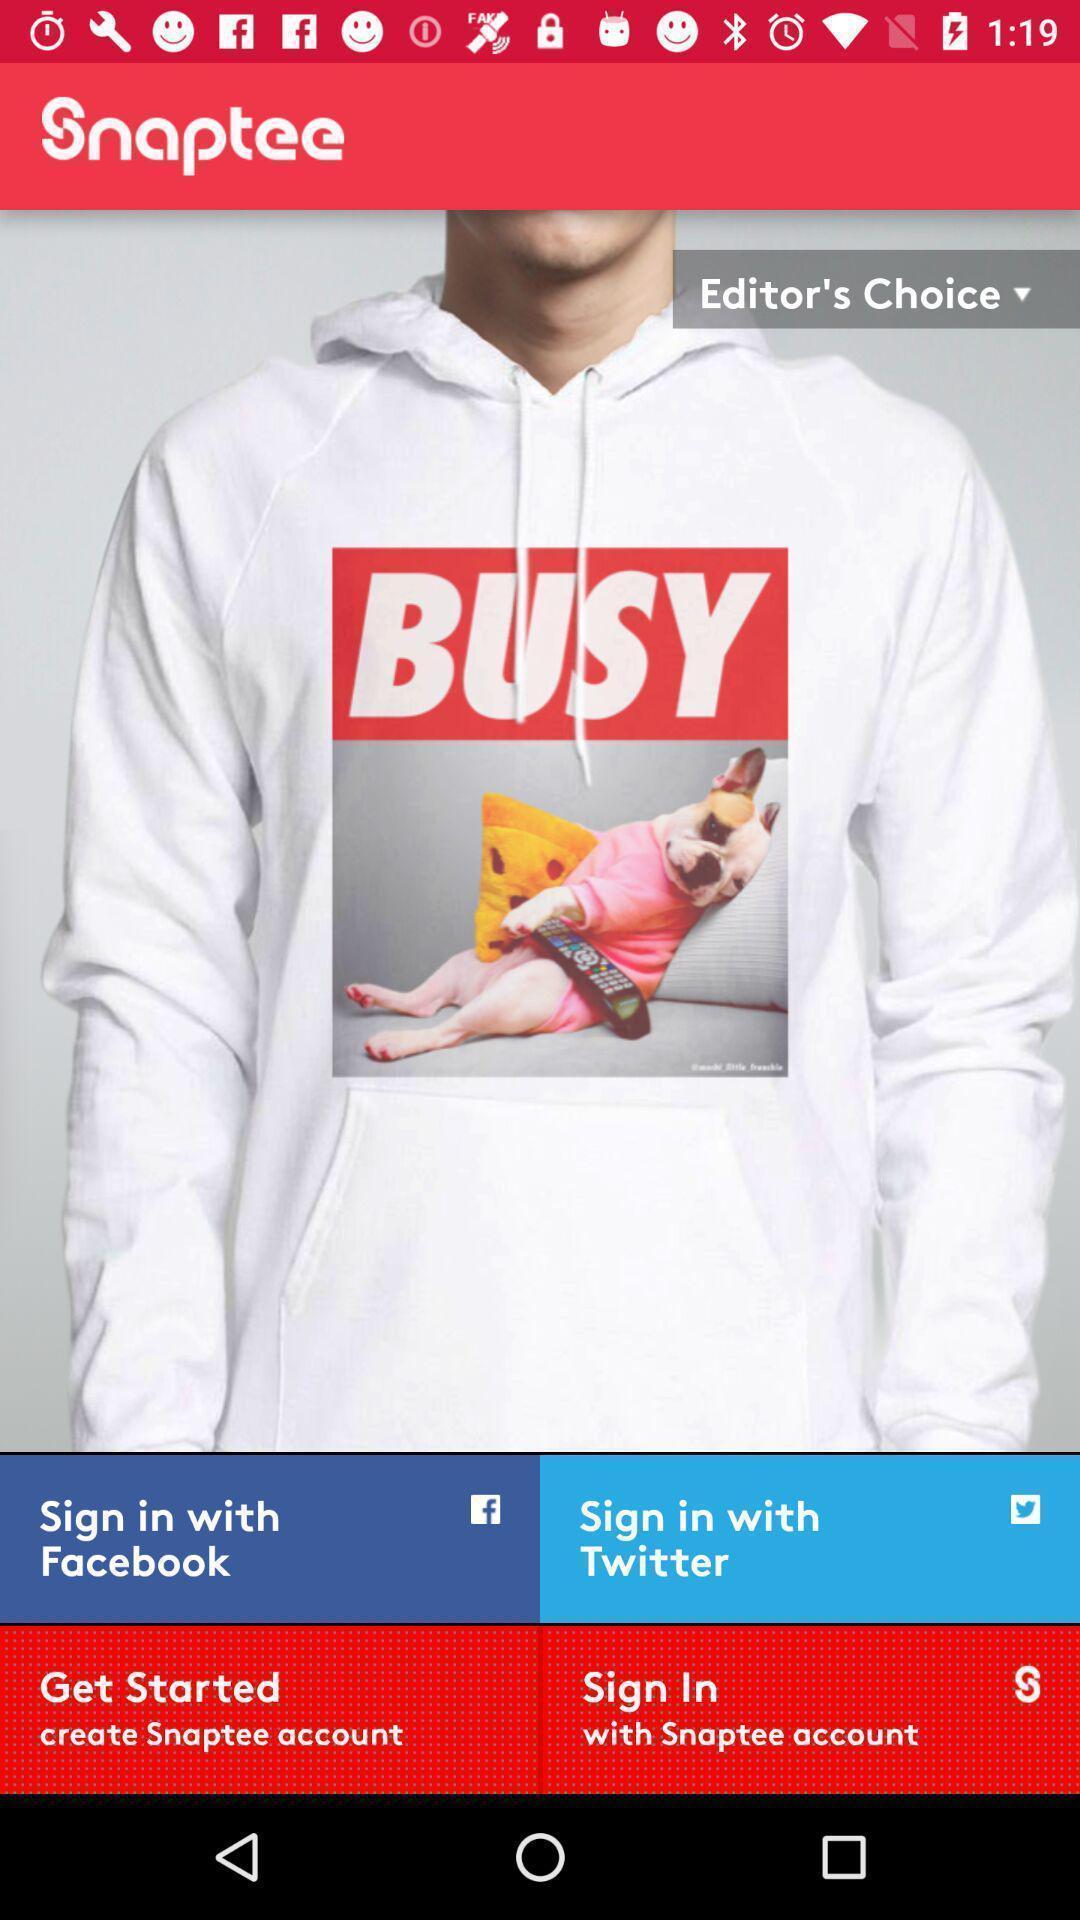Summarize the main components in this picture. Welcome page of a shopping app. 